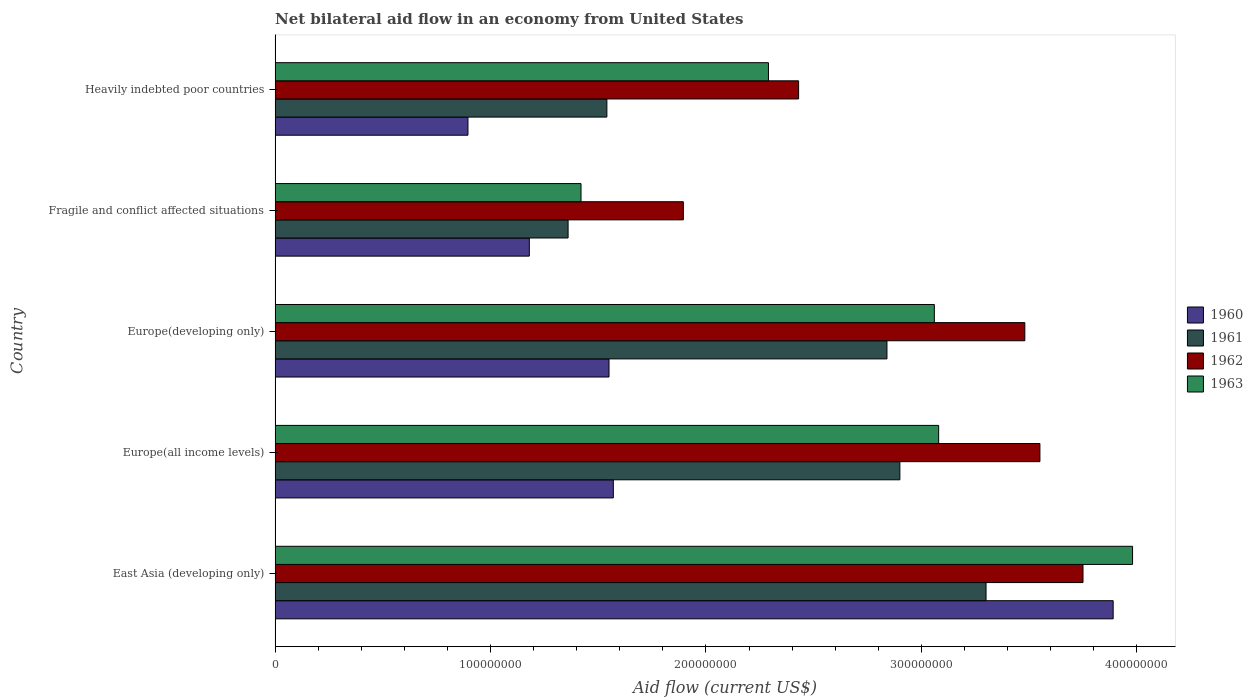How many groups of bars are there?
Ensure brevity in your answer.  5. Are the number of bars on each tick of the Y-axis equal?
Ensure brevity in your answer.  Yes. How many bars are there on the 1st tick from the bottom?
Your answer should be compact. 4. What is the label of the 1st group of bars from the top?
Your answer should be very brief. Heavily indebted poor countries. In how many cases, is the number of bars for a given country not equal to the number of legend labels?
Your answer should be very brief. 0. What is the net bilateral aid flow in 1961 in Heavily indebted poor countries?
Your answer should be compact. 1.54e+08. Across all countries, what is the maximum net bilateral aid flow in 1962?
Make the answer very short. 3.75e+08. Across all countries, what is the minimum net bilateral aid flow in 1963?
Offer a very short reply. 1.42e+08. In which country was the net bilateral aid flow in 1962 maximum?
Offer a very short reply. East Asia (developing only). In which country was the net bilateral aid flow in 1963 minimum?
Provide a succinct answer. Fragile and conflict affected situations. What is the total net bilateral aid flow in 1962 in the graph?
Give a very brief answer. 1.51e+09. What is the difference between the net bilateral aid flow in 1960 in Europe(all income levels) and that in Heavily indebted poor countries?
Provide a short and direct response. 6.75e+07. What is the difference between the net bilateral aid flow in 1962 in Fragile and conflict affected situations and the net bilateral aid flow in 1963 in Europe(developing only)?
Ensure brevity in your answer.  -1.16e+08. What is the average net bilateral aid flow in 1960 per country?
Give a very brief answer. 1.82e+08. What is the difference between the net bilateral aid flow in 1960 and net bilateral aid flow in 1962 in Europe(all income levels)?
Give a very brief answer. -1.98e+08. What is the ratio of the net bilateral aid flow in 1960 in Europe(developing only) to that in Heavily indebted poor countries?
Give a very brief answer. 1.73. What is the difference between the highest and the second highest net bilateral aid flow in 1962?
Provide a succinct answer. 2.00e+07. What is the difference between the highest and the lowest net bilateral aid flow in 1961?
Offer a terse response. 1.94e+08. In how many countries, is the net bilateral aid flow in 1960 greater than the average net bilateral aid flow in 1960 taken over all countries?
Make the answer very short. 1. Is it the case that in every country, the sum of the net bilateral aid flow in 1962 and net bilateral aid flow in 1963 is greater than the sum of net bilateral aid flow in 1960 and net bilateral aid flow in 1961?
Provide a short and direct response. No. What does the 1st bar from the bottom in East Asia (developing only) represents?
Make the answer very short. 1960. How many bars are there?
Make the answer very short. 20. What is the difference between two consecutive major ticks on the X-axis?
Your response must be concise. 1.00e+08. Are the values on the major ticks of X-axis written in scientific E-notation?
Your answer should be compact. No. Does the graph contain any zero values?
Offer a very short reply. No. Does the graph contain grids?
Provide a succinct answer. No. Where does the legend appear in the graph?
Your answer should be very brief. Center right. What is the title of the graph?
Provide a short and direct response. Net bilateral aid flow in an economy from United States. Does "1975" appear as one of the legend labels in the graph?
Provide a succinct answer. No. What is the label or title of the Y-axis?
Your answer should be very brief. Country. What is the Aid flow (current US$) in 1960 in East Asia (developing only)?
Your response must be concise. 3.89e+08. What is the Aid flow (current US$) of 1961 in East Asia (developing only)?
Give a very brief answer. 3.30e+08. What is the Aid flow (current US$) of 1962 in East Asia (developing only)?
Provide a succinct answer. 3.75e+08. What is the Aid flow (current US$) of 1963 in East Asia (developing only)?
Your response must be concise. 3.98e+08. What is the Aid flow (current US$) of 1960 in Europe(all income levels)?
Provide a succinct answer. 1.57e+08. What is the Aid flow (current US$) of 1961 in Europe(all income levels)?
Offer a terse response. 2.90e+08. What is the Aid flow (current US$) of 1962 in Europe(all income levels)?
Keep it short and to the point. 3.55e+08. What is the Aid flow (current US$) of 1963 in Europe(all income levels)?
Your answer should be compact. 3.08e+08. What is the Aid flow (current US$) of 1960 in Europe(developing only)?
Offer a terse response. 1.55e+08. What is the Aid flow (current US$) in 1961 in Europe(developing only)?
Your answer should be very brief. 2.84e+08. What is the Aid flow (current US$) in 1962 in Europe(developing only)?
Offer a terse response. 3.48e+08. What is the Aid flow (current US$) of 1963 in Europe(developing only)?
Offer a terse response. 3.06e+08. What is the Aid flow (current US$) in 1960 in Fragile and conflict affected situations?
Offer a terse response. 1.18e+08. What is the Aid flow (current US$) in 1961 in Fragile and conflict affected situations?
Your answer should be compact. 1.36e+08. What is the Aid flow (current US$) in 1962 in Fragile and conflict affected situations?
Your response must be concise. 1.90e+08. What is the Aid flow (current US$) of 1963 in Fragile and conflict affected situations?
Give a very brief answer. 1.42e+08. What is the Aid flow (current US$) of 1960 in Heavily indebted poor countries?
Your answer should be compact. 8.95e+07. What is the Aid flow (current US$) of 1961 in Heavily indebted poor countries?
Provide a short and direct response. 1.54e+08. What is the Aid flow (current US$) of 1962 in Heavily indebted poor countries?
Offer a very short reply. 2.43e+08. What is the Aid flow (current US$) of 1963 in Heavily indebted poor countries?
Offer a terse response. 2.29e+08. Across all countries, what is the maximum Aid flow (current US$) in 1960?
Provide a short and direct response. 3.89e+08. Across all countries, what is the maximum Aid flow (current US$) in 1961?
Give a very brief answer. 3.30e+08. Across all countries, what is the maximum Aid flow (current US$) in 1962?
Provide a short and direct response. 3.75e+08. Across all countries, what is the maximum Aid flow (current US$) in 1963?
Your answer should be very brief. 3.98e+08. Across all countries, what is the minimum Aid flow (current US$) in 1960?
Keep it short and to the point. 8.95e+07. Across all countries, what is the minimum Aid flow (current US$) in 1961?
Offer a terse response. 1.36e+08. Across all countries, what is the minimum Aid flow (current US$) in 1962?
Offer a terse response. 1.90e+08. Across all countries, what is the minimum Aid flow (current US$) of 1963?
Offer a very short reply. 1.42e+08. What is the total Aid flow (current US$) in 1960 in the graph?
Keep it short and to the point. 9.09e+08. What is the total Aid flow (current US$) of 1961 in the graph?
Ensure brevity in your answer.  1.19e+09. What is the total Aid flow (current US$) in 1962 in the graph?
Keep it short and to the point. 1.51e+09. What is the total Aid flow (current US$) of 1963 in the graph?
Make the answer very short. 1.38e+09. What is the difference between the Aid flow (current US$) in 1960 in East Asia (developing only) and that in Europe(all income levels)?
Your answer should be very brief. 2.32e+08. What is the difference between the Aid flow (current US$) of 1961 in East Asia (developing only) and that in Europe(all income levels)?
Your answer should be very brief. 4.00e+07. What is the difference between the Aid flow (current US$) of 1963 in East Asia (developing only) and that in Europe(all income levels)?
Your answer should be very brief. 9.00e+07. What is the difference between the Aid flow (current US$) in 1960 in East Asia (developing only) and that in Europe(developing only)?
Your answer should be very brief. 2.34e+08. What is the difference between the Aid flow (current US$) of 1961 in East Asia (developing only) and that in Europe(developing only)?
Give a very brief answer. 4.60e+07. What is the difference between the Aid flow (current US$) of 1962 in East Asia (developing only) and that in Europe(developing only)?
Provide a succinct answer. 2.70e+07. What is the difference between the Aid flow (current US$) of 1963 in East Asia (developing only) and that in Europe(developing only)?
Offer a very short reply. 9.20e+07. What is the difference between the Aid flow (current US$) of 1960 in East Asia (developing only) and that in Fragile and conflict affected situations?
Keep it short and to the point. 2.71e+08. What is the difference between the Aid flow (current US$) of 1961 in East Asia (developing only) and that in Fragile and conflict affected situations?
Ensure brevity in your answer.  1.94e+08. What is the difference between the Aid flow (current US$) in 1962 in East Asia (developing only) and that in Fragile and conflict affected situations?
Offer a terse response. 1.86e+08. What is the difference between the Aid flow (current US$) in 1963 in East Asia (developing only) and that in Fragile and conflict affected situations?
Provide a short and direct response. 2.56e+08. What is the difference between the Aid flow (current US$) in 1960 in East Asia (developing only) and that in Heavily indebted poor countries?
Ensure brevity in your answer.  2.99e+08. What is the difference between the Aid flow (current US$) of 1961 in East Asia (developing only) and that in Heavily indebted poor countries?
Your answer should be very brief. 1.76e+08. What is the difference between the Aid flow (current US$) of 1962 in East Asia (developing only) and that in Heavily indebted poor countries?
Your answer should be compact. 1.32e+08. What is the difference between the Aid flow (current US$) of 1963 in East Asia (developing only) and that in Heavily indebted poor countries?
Offer a terse response. 1.69e+08. What is the difference between the Aid flow (current US$) in 1960 in Europe(all income levels) and that in Europe(developing only)?
Provide a succinct answer. 2.00e+06. What is the difference between the Aid flow (current US$) of 1962 in Europe(all income levels) and that in Europe(developing only)?
Your answer should be compact. 7.00e+06. What is the difference between the Aid flow (current US$) of 1963 in Europe(all income levels) and that in Europe(developing only)?
Offer a terse response. 2.00e+06. What is the difference between the Aid flow (current US$) of 1960 in Europe(all income levels) and that in Fragile and conflict affected situations?
Ensure brevity in your answer.  3.90e+07. What is the difference between the Aid flow (current US$) in 1961 in Europe(all income levels) and that in Fragile and conflict affected situations?
Give a very brief answer. 1.54e+08. What is the difference between the Aid flow (current US$) in 1962 in Europe(all income levels) and that in Fragile and conflict affected situations?
Ensure brevity in your answer.  1.66e+08. What is the difference between the Aid flow (current US$) in 1963 in Europe(all income levels) and that in Fragile and conflict affected situations?
Ensure brevity in your answer.  1.66e+08. What is the difference between the Aid flow (current US$) in 1960 in Europe(all income levels) and that in Heavily indebted poor countries?
Make the answer very short. 6.75e+07. What is the difference between the Aid flow (current US$) in 1961 in Europe(all income levels) and that in Heavily indebted poor countries?
Offer a very short reply. 1.36e+08. What is the difference between the Aid flow (current US$) in 1962 in Europe(all income levels) and that in Heavily indebted poor countries?
Provide a short and direct response. 1.12e+08. What is the difference between the Aid flow (current US$) of 1963 in Europe(all income levels) and that in Heavily indebted poor countries?
Provide a succinct answer. 7.90e+07. What is the difference between the Aid flow (current US$) of 1960 in Europe(developing only) and that in Fragile and conflict affected situations?
Provide a succinct answer. 3.70e+07. What is the difference between the Aid flow (current US$) in 1961 in Europe(developing only) and that in Fragile and conflict affected situations?
Offer a very short reply. 1.48e+08. What is the difference between the Aid flow (current US$) in 1962 in Europe(developing only) and that in Fragile and conflict affected situations?
Keep it short and to the point. 1.58e+08. What is the difference between the Aid flow (current US$) in 1963 in Europe(developing only) and that in Fragile and conflict affected situations?
Provide a succinct answer. 1.64e+08. What is the difference between the Aid flow (current US$) in 1960 in Europe(developing only) and that in Heavily indebted poor countries?
Ensure brevity in your answer.  6.55e+07. What is the difference between the Aid flow (current US$) of 1961 in Europe(developing only) and that in Heavily indebted poor countries?
Provide a short and direct response. 1.30e+08. What is the difference between the Aid flow (current US$) in 1962 in Europe(developing only) and that in Heavily indebted poor countries?
Your answer should be very brief. 1.05e+08. What is the difference between the Aid flow (current US$) in 1963 in Europe(developing only) and that in Heavily indebted poor countries?
Your answer should be very brief. 7.70e+07. What is the difference between the Aid flow (current US$) in 1960 in Fragile and conflict affected situations and that in Heavily indebted poor countries?
Make the answer very short. 2.85e+07. What is the difference between the Aid flow (current US$) of 1961 in Fragile and conflict affected situations and that in Heavily indebted poor countries?
Provide a succinct answer. -1.80e+07. What is the difference between the Aid flow (current US$) in 1962 in Fragile and conflict affected situations and that in Heavily indebted poor countries?
Provide a succinct answer. -5.35e+07. What is the difference between the Aid flow (current US$) in 1963 in Fragile and conflict affected situations and that in Heavily indebted poor countries?
Your answer should be compact. -8.70e+07. What is the difference between the Aid flow (current US$) in 1960 in East Asia (developing only) and the Aid flow (current US$) in 1961 in Europe(all income levels)?
Ensure brevity in your answer.  9.90e+07. What is the difference between the Aid flow (current US$) in 1960 in East Asia (developing only) and the Aid flow (current US$) in 1962 in Europe(all income levels)?
Provide a succinct answer. 3.40e+07. What is the difference between the Aid flow (current US$) in 1960 in East Asia (developing only) and the Aid flow (current US$) in 1963 in Europe(all income levels)?
Give a very brief answer. 8.10e+07. What is the difference between the Aid flow (current US$) in 1961 in East Asia (developing only) and the Aid flow (current US$) in 1962 in Europe(all income levels)?
Provide a short and direct response. -2.50e+07. What is the difference between the Aid flow (current US$) of 1961 in East Asia (developing only) and the Aid flow (current US$) of 1963 in Europe(all income levels)?
Offer a terse response. 2.20e+07. What is the difference between the Aid flow (current US$) in 1962 in East Asia (developing only) and the Aid flow (current US$) in 1963 in Europe(all income levels)?
Make the answer very short. 6.70e+07. What is the difference between the Aid flow (current US$) in 1960 in East Asia (developing only) and the Aid flow (current US$) in 1961 in Europe(developing only)?
Provide a short and direct response. 1.05e+08. What is the difference between the Aid flow (current US$) of 1960 in East Asia (developing only) and the Aid flow (current US$) of 1962 in Europe(developing only)?
Your answer should be very brief. 4.10e+07. What is the difference between the Aid flow (current US$) of 1960 in East Asia (developing only) and the Aid flow (current US$) of 1963 in Europe(developing only)?
Give a very brief answer. 8.30e+07. What is the difference between the Aid flow (current US$) in 1961 in East Asia (developing only) and the Aid flow (current US$) in 1962 in Europe(developing only)?
Your answer should be very brief. -1.80e+07. What is the difference between the Aid flow (current US$) in 1961 in East Asia (developing only) and the Aid flow (current US$) in 1963 in Europe(developing only)?
Offer a terse response. 2.40e+07. What is the difference between the Aid flow (current US$) of 1962 in East Asia (developing only) and the Aid flow (current US$) of 1963 in Europe(developing only)?
Give a very brief answer. 6.90e+07. What is the difference between the Aid flow (current US$) of 1960 in East Asia (developing only) and the Aid flow (current US$) of 1961 in Fragile and conflict affected situations?
Offer a terse response. 2.53e+08. What is the difference between the Aid flow (current US$) in 1960 in East Asia (developing only) and the Aid flow (current US$) in 1962 in Fragile and conflict affected situations?
Your answer should be very brief. 2.00e+08. What is the difference between the Aid flow (current US$) in 1960 in East Asia (developing only) and the Aid flow (current US$) in 1963 in Fragile and conflict affected situations?
Your answer should be compact. 2.47e+08. What is the difference between the Aid flow (current US$) in 1961 in East Asia (developing only) and the Aid flow (current US$) in 1962 in Fragile and conflict affected situations?
Offer a very short reply. 1.40e+08. What is the difference between the Aid flow (current US$) in 1961 in East Asia (developing only) and the Aid flow (current US$) in 1963 in Fragile and conflict affected situations?
Ensure brevity in your answer.  1.88e+08. What is the difference between the Aid flow (current US$) of 1962 in East Asia (developing only) and the Aid flow (current US$) of 1963 in Fragile and conflict affected situations?
Offer a terse response. 2.33e+08. What is the difference between the Aid flow (current US$) of 1960 in East Asia (developing only) and the Aid flow (current US$) of 1961 in Heavily indebted poor countries?
Provide a succinct answer. 2.35e+08. What is the difference between the Aid flow (current US$) in 1960 in East Asia (developing only) and the Aid flow (current US$) in 1962 in Heavily indebted poor countries?
Offer a very short reply. 1.46e+08. What is the difference between the Aid flow (current US$) of 1960 in East Asia (developing only) and the Aid flow (current US$) of 1963 in Heavily indebted poor countries?
Give a very brief answer. 1.60e+08. What is the difference between the Aid flow (current US$) in 1961 in East Asia (developing only) and the Aid flow (current US$) in 1962 in Heavily indebted poor countries?
Your answer should be compact. 8.70e+07. What is the difference between the Aid flow (current US$) of 1961 in East Asia (developing only) and the Aid flow (current US$) of 1963 in Heavily indebted poor countries?
Provide a short and direct response. 1.01e+08. What is the difference between the Aid flow (current US$) in 1962 in East Asia (developing only) and the Aid flow (current US$) in 1963 in Heavily indebted poor countries?
Provide a succinct answer. 1.46e+08. What is the difference between the Aid flow (current US$) of 1960 in Europe(all income levels) and the Aid flow (current US$) of 1961 in Europe(developing only)?
Provide a succinct answer. -1.27e+08. What is the difference between the Aid flow (current US$) in 1960 in Europe(all income levels) and the Aid flow (current US$) in 1962 in Europe(developing only)?
Ensure brevity in your answer.  -1.91e+08. What is the difference between the Aid flow (current US$) of 1960 in Europe(all income levels) and the Aid flow (current US$) of 1963 in Europe(developing only)?
Provide a succinct answer. -1.49e+08. What is the difference between the Aid flow (current US$) in 1961 in Europe(all income levels) and the Aid flow (current US$) in 1962 in Europe(developing only)?
Your response must be concise. -5.80e+07. What is the difference between the Aid flow (current US$) of 1961 in Europe(all income levels) and the Aid flow (current US$) of 1963 in Europe(developing only)?
Your response must be concise. -1.60e+07. What is the difference between the Aid flow (current US$) of 1962 in Europe(all income levels) and the Aid flow (current US$) of 1963 in Europe(developing only)?
Ensure brevity in your answer.  4.90e+07. What is the difference between the Aid flow (current US$) in 1960 in Europe(all income levels) and the Aid flow (current US$) in 1961 in Fragile and conflict affected situations?
Make the answer very short. 2.10e+07. What is the difference between the Aid flow (current US$) in 1960 in Europe(all income levels) and the Aid flow (current US$) in 1962 in Fragile and conflict affected situations?
Your response must be concise. -3.25e+07. What is the difference between the Aid flow (current US$) in 1960 in Europe(all income levels) and the Aid flow (current US$) in 1963 in Fragile and conflict affected situations?
Your answer should be compact. 1.50e+07. What is the difference between the Aid flow (current US$) of 1961 in Europe(all income levels) and the Aid flow (current US$) of 1962 in Fragile and conflict affected situations?
Keep it short and to the point. 1.00e+08. What is the difference between the Aid flow (current US$) of 1961 in Europe(all income levels) and the Aid flow (current US$) of 1963 in Fragile and conflict affected situations?
Your answer should be compact. 1.48e+08. What is the difference between the Aid flow (current US$) in 1962 in Europe(all income levels) and the Aid flow (current US$) in 1963 in Fragile and conflict affected situations?
Your response must be concise. 2.13e+08. What is the difference between the Aid flow (current US$) in 1960 in Europe(all income levels) and the Aid flow (current US$) in 1962 in Heavily indebted poor countries?
Provide a short and direct response. -8.60e+07. What is the difference between the Aid flow (current US$) in 1960 in Europe(all income levels) and the Aid flow (current US$) in 1963 in Heavily indebted poor countries?
Keep it short and to the point. -7.20e+07. What is the difference between the Aid flow (current US$) in 1961 in Europe(all income levels) and the Aid flow (current US$) in 1962 in Heavily indebted poor countries?
Ensure brevity in your answer.  4.70e+07. What is the difference between the Aid flow (current US$) in 1961 in Europe(all income levels) and the Aid flow (current US$) in 1963 in Heavily indebted poor countries?
Your response must be concise. 6.10e+07. What is the difference between the Aid flow (current US$) in 1962 in Europe(all income levels) and the Aid flow (current US$) in 1963 in Heavily indebted poor countries?
Provide a succinct answer. 1.26e+08. What is the difference between the Aid flow (current US$) in 1960 in Europe(developing only) and the Aid flow (current US$) in 1961 in Fragile and conflict affected situations?
Offer a terse response. 1.90e+07. What is the difference between the Aid flow (current US$) in 1960 in Europe(developing only) and the Aid flow (current US$) in 1962 in Fragile and conflict affected situations?
Your answer should be very brief. -3.45e+07. What is the difference between the Aid flow (current US$) of 1960 in Europe(developing only) and the Aid flow (current US$) of 1963 in Fragile and conflict affected situations?
Keep it short and to the point. 1.30e+07. What is the difference between the Aid flow (current US$) of 1961 in Europe(developing only) and the Aid flow (current US$) of 1962 in Fragile and conflict affected situations?
Your answer should be very brief. 9.45e+07. What is the difference between the Aid flow (current US$) of 1961 in Europe(developing only) and the Aid flow (current US$) of 1963 in Fragile and conflict affected situations?
Keep it short and to the point. 1.42e+08. What is the difference between the Aid flow (current US$) in 1962 in Europe(developing only) and the Aid flow (current US$) in 1963 in Fragile and conflict affected situations?
Give a very brief answer. 2.06e+08. What is the difference between the Aid flow (current US$) in 1960 in Europe(developing only) and the Aid flow (current US$) in 1962 in Heavily indebted poor countries?
Provide a succinct answer. -8.80e+07. What is the difference between the Aid flow (current US$) in 1960 in Europe(developing only) and the Aid flow (current US$) in 1963 in Heavily indebted poor countries?
Provide a succinct answer. -7.40e+07. What is the difference between the Aid flow (current US$) of 1961 in Europe(developing only) and the Aid flow (current US$) of 1962 in Heavily indebted poor countries?
Give a very brief answer. 4.10e+07. What is the difference between the Aid flow (current US$) of 1961 in Europe(developing only) and the Aid flow (current US$) of 1963 in Heavily indebted poor countries?
Give a very brief answer. 5.50e+07. What is the difference between the Aid flow (current US$) of 1962 in Europe(developing only) and the Aid flow (current US$) of 1963 in Heavily indebted poor countries?
Give a very brief answer. 1.19e+08. What is the difference between the Aid flow (current US$) in 1960 in Fragile and conflict affected situations and the Aid flow (current US$) in 1961 in Heavily indebted poor countries?
Offer a terse response. -3.60e+07. What is the difference between the Aid flow (current US$) in 1960 in Fragile and conflict affected situations and the Aid flow (current US$) in 1962 in Heavily indebted poor countries?
Make the answer very short. -1.25e+08. What is the difference between the Aid flow (current US$) in 1960 in Fragile and conflict affected situations and the Aid flow (current US$) in 1963 in Heavily indebted poor countries?
Your answer should be compact. -1.11e+08. What is the difference between the Aid flow (current US$) of 1961 in Fragile and conflict affected situations and the Aid flow (current US$) of 1962 in Heavily indebted poor countries?
Your response must be concise. -1.07e+08. What is the difference between the Aid flow (current US$) of 1961 in Fragile and conflict affected situations and the Aid flow (current US$) of 1963 in Heavily indebted poor countries?
Provide a short and direct response. -9.30e+07. What is the difference between the Aid flow (current US$) in 1962 in Fragile and conflict affected situations and the Aid flow (current US$) in 1963 in Heavily indebted poor countries?
Give a very brief answer. -3.95e+07. What is the average Aid flow (current US$) in 1960 per country?
Keep it short and to the point. 1.82e+08. What is the average Aid flow (current US$) in 1961 per country?
Offer a very short reply. 2.39e+08. What is the average Aid flow (current US$) of 1962 per country?
Give a very brief answer. 3.02e+08. What is the average Aid flow (current US$) of 1963 per country?
Offer a terse response. 2.77e+08. What is the difference between the Aid flow (current US$) in 1960 and Aid flow (current US$) in 1961 in East Asia (developing only)?
Your response must be concise. 5.90e+07. What is the difference between the Aid flow (current US$) of 1960 and Aid flow (current US$) of 1962 in East Asia (developing only)?
Offer a very short reply. 1.40e+07. What is the difference between the Aid flow (current US$) in 1960 and Aid flow (current US$) in 1963 in East Asia (developing only)?
Your answer should be compact. -9.00e+06. What is the difference between the Aid flow (current US$) of 1961 and Aid flow (current US$) of 1962 in East Asia (developing only)?
Offer a terse response. -4.50e+07. What is the difference between the Aid flow (current US$) in 1961 and Aid flow (current US$) in 1963 in East Asia (developing only)?
Keep it short and to the point. -6.80e+07. What is the difference between the Aid flow (current US$) of 1962 and Aid flow (current US$) of 1963 in East Asia (developing only)?
Offer a terse response. -2.30e+07. What is the difference between the Aid flow (current US$) in 1960 and Aid flow (current US$) in 1961 in Europe(all income levels)?
Your answer should be compact. -1.33e+08. What is the difference between the Aid flow (current US$) in 1960 and Aid flow (current US$) in 1962 in Europe(all income levels)?
Your answer should be very brief. -1.98e+08. What is the difference between the Aid flow (current US$) in 1960 and Aid flow (current US$) in 1963 in Europe(all income levels)?
Keep it short and to the point. -1.51e+08. What is the difference between the Aid flow (current US$) of 1961 and Aid flow (current US$) of 1962 in Europe(all income levels)?
Provide a short and direct response. -6.50e+07. What is the difference between the Aid flow (current US$) in 1961 and Aid flow (current US$) in 1963 in Europe(all income levels)?
Keep it short and to the point. -1.80e+07. What is the difference between the Aid flow (current US$) of 1962 and Aid flow (current US$) of 1963 in Europe(all income levels)?
Provide a succinct answer. 4.70e+07. What is the difference between the Aid flow (current US$) of 1960 and Aid flow (current US$) of 1961 in Europe(developing only)?
Keep it short and to the point. -1.29e+08. What is the difference between the Aid flow (current US$) in 1960 and Aid flow (current US$) in 1962 in Europe(developing only)?
Provide a succinct answer. -1.93e+08. What is the difference between the Aid flow (current US$) in 1960 and Aid flow (current US$) in 1963 in Europe(developing only)?
Ensure brevity in your answer.  -1.51e+08. What is the difference between the Aid flow (current US$) of 1961 and Aid flow (current US$) of 1962 in Europe(developing only)?
Offer a very short reply. -6.40e+07. What is the difference between the Aid flow (current US$) of 1961 and Aid flow (current US$) of 1963 in Europe(developing only)?
Ensure brevity in your answer.  -2.20e+07. What is the difference between the Aid flow (current US$) in 1962 and Aid flow (current US$) in 1963 in Europe(developing only)?
Offer a very short reply. 4.20e+07. What is the difference between the Aid flow (current US$) of 1960 and Aid flow (current US$) of 1961 in Fragile and conflict affected situations?
Offer a very short reply. -1.80e+07. What is the difference between the Aid flow (current US$) in 1960 and Aid flow (current US$) in 1962 in Fragile and conflict affected situations?
Your answer should be compact. -7.15e+07. What is the difference between the Aid flow (current US$) of 1960 and Aid flow (current US$) of 1963 in Fragile and conflict affected situations?
Your answer should be compact. -2.40e+07. What is the difference between the Aid flow (current US$) in 1961 and Aid flow (current US$) in 1962 in Fragile and conflict affected situations?
Keep it short and to the point. -5.35e+07. What is the difference between the Aid flow (current US$) of 1961 and Aid flow (current US$) of 1963 in Fragile and conflict affected situations?
Your answer should be compact. -6.00e+06. What is the difference between the Aid flow (current US$) of 1962 and Aid flow (current US$) of 1963 in Fragile and conflict affected situations?
Your answer should be compact. 4.75e+07. What is the difference between the Aid flow (current US$) of 1960 and Aid flow (current US$) of 1961 in Heavily indebted poor countries?
Ensure brevity in your answer.  -6.45e+07. What is the difference between the Aid flow (current US$) in 1960 and Aid flow (current US$) in 1962 in Heavily indebted poor countries?
Give a very brief answer. -1.53e+08. What is the difference between the Aid flow (current US$) in 1960 and Aid flow (current US$) in 1963 in Heavily indebted poor countries?
Keep it short and to the point. -1.39e+08. What is the difference between the Aid flow (current US$) of 1961 and Aid flow (current US$) of 1962 in Heavily indebted poor countries?
Provide a succinct answer. -8.90e+07. What is the difference between the Aid flow (current US$) in 1961 and Aid flow (current US$) in 1963 in Heavily indebted poor countries?
Keep it short and to the point. -7.50e+07. What is the difference between the Aid flow (current US$) in 1962 and Aid flow (current US$) in 1963 in Heavily indebted poor countries?
Your answer should be very brief. 1.40e+07. What is the ratio of the Aid flow (current US$) of 1960 in East Asia (developing only) to that in Europe(all income levels)?
Provide a succinct answer. 2.48. What is the ratio of the Aid flow (current US$) of 1961 in East Asia (developing only) to that in Europe(all income levels)?
Keep it short and to the point. 1.14. What is the ratio of the Aid flow (current US$) in 1962 in East Asia (developing only) to that in Europe(all income levels)?
Keep it short and to the point. 1.06. What is the ratio of the Aid flow (current US$) of 1963 in East Asia (developing only) to that in Europe(all income levels)?
Provide a short and direct response. 1.29. What is the ratio of the Aid flow (current US$) of 1960 in East Asia (developing only) to that in Europe(developing only)?
Your answer should be very brief. 2.51. What is the ratio of the Aid flow (current US$) in 1961 in East Asia (developing only) to that in Europe(developing only)?
Your answer should be compact. 1.16. What is the ratio of the Aid flow (current US$) of 1962 in East Asia (developing only) to that in Europe(developing only)?
Offer a very short reply. 1.08. What is the ratio of the Aid flow (current US$) in 1963 in East Asia (developing only) to that in Europe(developing only)?
Provide a short and direct response. 1.3. What is the ratio of the Aid flow (current US$) in 1960 in East Asia (developing only) to that in Fragile and conflict affected situations?
Make the answer very short. 3.3. What is the ratio of the Aid flow (current US$) of 1961 in East Asia (developing only) to that in Fragile and conflict affected situations?
Provide a succinct answer. 2.43. What is the ratio of the Aid flow (current US$) in 1962 in East Asia (developing only) to that in Fragile and conflict affected situations?
Your answer should be compact. 1.98. What is the ratio of the Aid flow (current US$) in 1963 in East Asia (developing only) to that in Fragile and conflict affected situations?
Offer a very short reply. 2.8. What is the ratio of the Aid flow (current US$) of 1960 in East Asia (developing only) to that in Heavily indebted poor countries?
Your response must be concise. 4.35. What is the ratio of the Aid flow (current US$) in 1961 in East Asia (developing only) to that in Heavily indebted poor countries?
Provide a short and direct response. 2.14. What is the ratio of the Aid flow (current US$) of 1962 in East Asia (developing only) to that in Heavily indebted poor countries?
Provide a short and direct response. 1.54. What is the ratio of the Aid flow (current US$) in 1963 in East Asia (developing only) to that in Heavily indebted poor countries?
Ensure brevity in your answer.  1.74. What is the ratio of the Aid flow (current US$) of 1960 in Europe(all income levels) to that in Europe(developing only)?
Offer a terse response. 1.01. What is the ratio of the Aid flow (current US$) of 1961 in Europe(all income levels) to that in Europe(developing only)?
Offer a terse response. 1.02. What is the ratio of the Aid flow (current US$) of 1962 in Europe(all income levels) to that in Europe(developing only)?
Offer a very short reply. 1.02. What is the ratio of the Aid flow (current US$) of 1963 in Europe(all income levels) to that in Europe(developing only)?
Provide a short and direct response. 1.01. What is the ratio of the Aid flow (current US$) in 1960 in Europe(all income levels) to that in Fragile and conflict affected situations?
Keep it short and to the point. 1.33. What is the ratio of the Aid flow (current US$) in 1961 in Europe(all income levels) to that in Fragile and conflict affected situations?
Offer a very short reply. 2.13. What is the ratio of the Aid flow (current US$) of 1962 in Europe(all income levels) to that in Fragile and conflict affected situations?
Offer a terse response. 1.87. What is the ratio of the Aid flow (current US$) of 1963 in Europe(all income levels) to that in Fragile and conflict affected situations?
Make the answer very short. 2.17. What is the ratio of the Aid flow (current US$) of 1960 in Europe(all income levels) to that in Heavily indebted poor countries?
Offer a very short reply. 1.75. What is the ratio of the Aid flow (current US$) of 1961 in Europe(all income levels) to that in Heavily indebted poor countries?
Provide a short and direct response. 1.88. What is the ratio of the Aid flow (current US$) in 1962 in Europe(all income levels) to that in Heavily indebted poor countries?
Make the answer very short. 1.46. What is the ratio of the Aid flow (current US$) of 1963 in Europe(all income levels) to that in Heavily indebted poor countries?
Your answer should be very brief. 1.34. What is the ratio of the Aid flow (current US$) in 1960 in Europe(developing only) to that in Fragile and conflict affected situations?
Offer a very short reply. 1.31. What is the ratio of the Aid flow (current US$) of 1961 in Europe(developing only) to that in Fragile and conflict affected situations?
Your answer should be compact. 2.09. What is the ratio of the Aid flow (current US$) of 1962 in Europe(developing only) to that in Fragile and conflict affected situations?
Ensure brevity in your answer.  1.84. What is the ratio of the Aid flow (current US$) of 1963 in Europe(developing only) to that in Fragile and conflict affected situations?
Provide a short and direct response. 2.15. What is the ratio of the Aid flow (current US$) of 1960 in Europe(developing only) to that in Heavily indebted poor countries?
Give a very brief answer. 1.73. What is the ratio of the Aid flow (current US$) in 1961 in Europe(developing only) to that in Heavily indebted poor countries?
Ensure brevity in your answer.  1.84. What is the ratio of the Aid flow (current US$) of 1962 in Europe(developing only) to that in Heavily indebted poor countries?
Keep it short and to the point. 1.43. What is the ratio of the Aid flow (current US$) in 1963 in Europe(developing only) to that in Heavily indebted poor countries?
Give a very brief answer. 1.34. What is the ratio of the Aid flow (current US$) in 1960 in Fragile and conflict affected situations to that in Heavily indebted poor countries?
Provide a short and direct response. 1.32. What is the ratio of the Aid flow (current US$) in 1961 in Fragile and conflict affected situations to that in Heavily indebted poor countries?
Your answer should be compact. 0.88. What is the ratio of the Aid flow (current US$) in 1962 in Fragile and conflict affected situations to that in Heavily indebted poor countries?
Offer a very short reply. 0.78. What is the ratio of the Aid flow (current US$) of 1963 in Fragile and conflict affected situations to that in Heavily indebted poor countries?
Ensure brevity in your answer.  0.62. What is the difference between the highest and the second highest Aid flow (current US$) of 1960?
Keep it short and to the point. 2.32e+08. What is the difference between the highest and the second highest Aid flow (current US$) in 1961?
Make the answer very short. 4.00e+07. What is the difference between the highest and the second highest Aid flow (current US$) of 1963?
Offer a terse response. 9.00e+07. What is the difference between the highest and the lowest Aid flow (current US$) in 1960?
Give a very brief answer. 2.99e+08. What is the difference between the highest and the lowest Aid flow (current US$) of 1961?
Give a very brief answer. 1.94e+08. What is the difference between the highest and the lowest Aid flow (current US$) in 1962?
Provide a succinct answer. 1.86e+08. What is the difference between the highest and the lowest Aid flow (current US$) of 1963?
Your answer should be compact. 2.56e+08. 